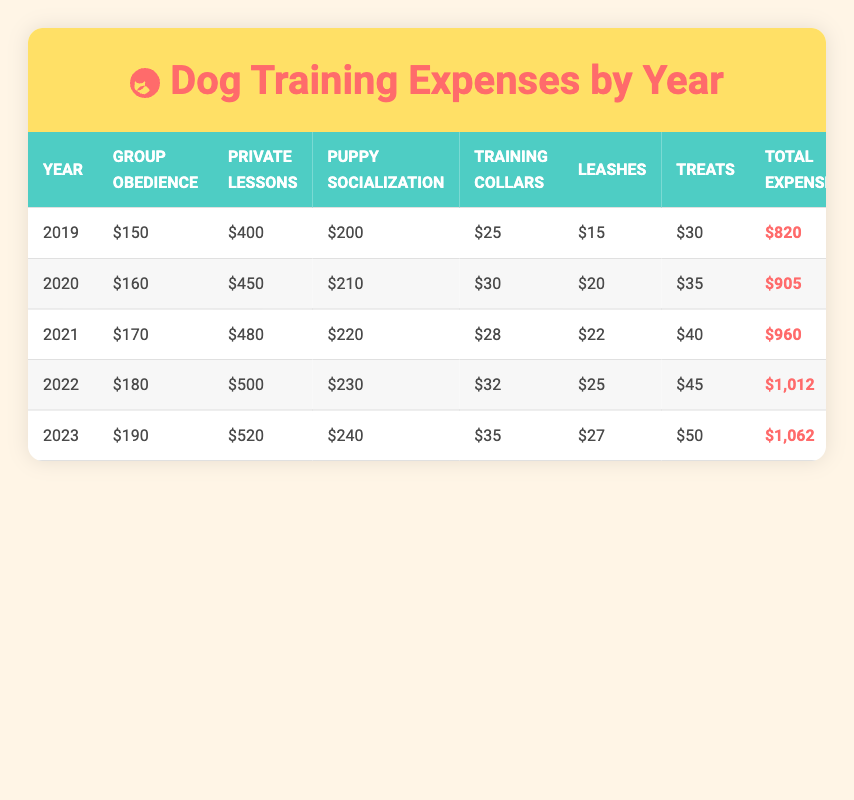What was the highest total expense recorded for dog training? The highest total expense can be found by locating the maximum value in the "Total Expense" column, which is $1,062 for the year 2023.
Answer: 1,062 What is the total expense for dog training in 2020? By looking at the "Total Expense" column for the year 2020, the total expense is listed as $905.
Answer: 905 Which year had the lowest expense for training collars? The training collars expense amounts are listed as $25 in 2019, $30 in 2020, $28 in 2021, $32 in 2022, and $35 in 2023. The lowest expense is $25 for 2019.
Answer: 2019 What is the average total expense over the five years? To find the average total expense, we add the total expenses for all five years ($820 + $905 + $960 + $1,012 + $1,062 = $4,759) and divide by the number of years (5). The average is $4,759 / 5 = $951.8.
Answer: 951.8 Did the expense for private lessons increase every year? We compare the expenses for private lessons from each year: $400 (2019), $450 (2020), $480 (2021), $500 (2022), and $520 (2023). Each value is greater than the previous year, confirming that expenses did increase every year.
Answer: Yes In which year did the combined expenses for supplies exceed $100? To find the combined supplies expenses, we sum the values for each year: 2019 ($25 + $15 + $30 = $70), 2020 ($30 + $20 + $35 = $85), 2021 ($28 + $22 + $40 = $90), 2022 ($32 + $25 + $45 = $102), and 2023 ($35 + $27 + $50 = $112). The combined expenses exceeded $100 in 2022 and 2023.
Answer: 2022, 2023 What was the total increase in total expenses from 2019 to 2023? The total expense in 2019 was $820 and in 2023 it was $1,062. The increase is calculated as $1,062 - $820 = $242.
Answer: 242 Was the expense for puppy socialization the same every year? Looking at the expenses for puppy socialization, we have $200 (2019), $210 (2020), $220 (2021), $230 (2022), and $240 (2023). Since these amounts increase each year, they were not the same.
Answer: No 